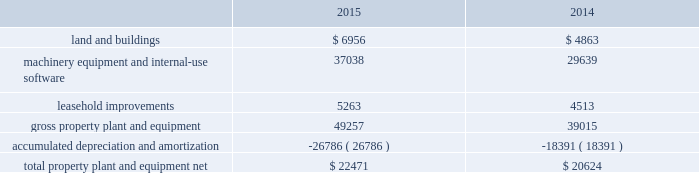Table of contents the notional amounts for outstanding derivative instruments provide one measure of the transaction volume outstanding and do not represent the amount of the company 2019s exposure to credit or market loss .
The credit risk amounts represent the company 2019s gross exposure to potential accounting loss on derivative instruments that are outstanding or unsettled if all counterparties failed to perform according to the terms of the contract , based on then-current currency or interest rates at each respective date .
The company 2019s exposure to credit loss and market risk will vary over time as currency and interest rates change .
Although the table above reflects the notional and credit risk amounts of the company 2019s derivative instruments , it does not reflect the gains or losses associated with the exposures and transactions that the instruments are intended to hedge .
The amounts ultimately realized upon settlement of these financial instruments , together with the gains and losses on the underlying exposures , will depend on actual market conditions during the remaining life of the instruments .
The company generally enters into master netting arrangements , which are designed to reduce credit risk by permitting net settlement of transactions with the same counterparty .
To further limit credit risk , the company generally enters into collateral security arrangements that provide for collateral to be received or posted when the net fair value of certain financial instruments fluctuates from contractually established thresholds .
The company presents its derivative assets and derivative liabilities at their gross fair values in its consolidated balance sheets .
The net cash collateral received by the company related to derivative instruments under its collateral security arrangements was $ 1.0 billion as of september 26 , 2015 and $ 2.1 billion as of september 27 , 2014 .
Under master netting arrangements with the respective counterparties to the company 2019s derivative contracts , the company is allowed to net settle transactions with a single net amount payable by one party to the other .
As of september 26 , 2015 and september 27 , 2014 , the potential effects of these rights of set-off associated with the company 2019s derivative contracts , including the effects of collateral , would be a reduction to both derivative assets and derivative liabilities of $ 2.2 billion and $ 1.6 billion , respectively , resulting in net derivative liabilities of $ 78 million and $ 549 million , respectively .
Accounts receivable receivables the company has considerable trade receivables outstanding with its third-party cellular network carriers , wholesalers , retailers , value-added resellers , small and mid-sized businesses and education , enterprise and government customers .
The company generally does not require collateral from its customers ; however , the company will require collateral in certain instances to limit credit risk .
In addition , when possible , the company attempts to limit credit risk on trade receivables with credit insurance for certain customers or by requiring third-party financing , loans or leases to support credit exposure .
These credit-financing arrangements are directly between the third-party financing company and the end customer .
As such , the company generally does not assume any recourse or credit risk sharing related to any of these arrangements .
As of september 26 , 2015 , the company had one customer that represented 10% ( 10 % ) or more of total trade receivables , which accounted for 12% ( 12 % ) .
As of september 27 , 2014 , the company had two customers that represented 10% ( 10 % ) or more of total trade receivables , one of which accounted for 16% ( 16 % ) and the other 13% ( 13 % ) .
The company 2019s cellular network carriers accounted for 71% ( 71 % ) and 72% ( 72 % ) of trade receivables as of september 26 , 2015 and september 27 , 2014 , respectively .
Vendor non-trade receivables the company has non-trade receivables from certain of its manufacturing vendors resulting from the sale of components to these vendors who manufacture sub-assemblies or assemble final products for the company .
The company purchases these components directly from suppliers .
Vendor non-trade receivables from three of the company 2019s vendors accounted for 38% ( 38 % ) , 18% ( 18 % ) and 14% ( 14 % ) of total vendor non-trade receivables as of september 26 , 2015 and three of the company 2019s vendors accounted for 51% ( 51 % ) , 16% ( 16 % ) and 14% ( 14 % ) of total vendor non-trade receivables as of september 27 , 2014 .
Note 3 2013 consolidated financial statement details the tables show the company 2019s consolidated financial statement details as of september 26 , 2015 and september 27 , 2014 ( in millions ) : property , plant and equipment , net .
Apple inc .
| 2015 form 10-k | 53 .
As of september 27 , 2014 , what percentage of total trade receivables did the company's two largest customers account for ? 
Computations: (16 + 13)
Answer: 29.0. 